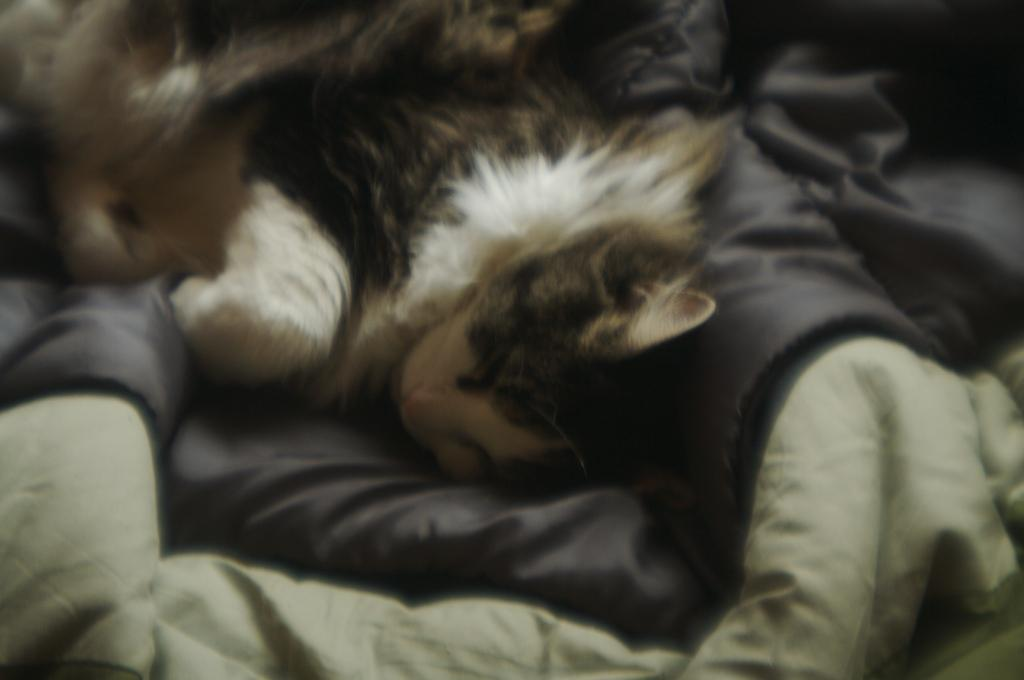What type of animal is in the image? There is a cat in the image. Where is the cat located? The cat is on the bed. What type of camp can be seen in the background of the image? There is no camp present in the image; it only features a cat on a bed. 